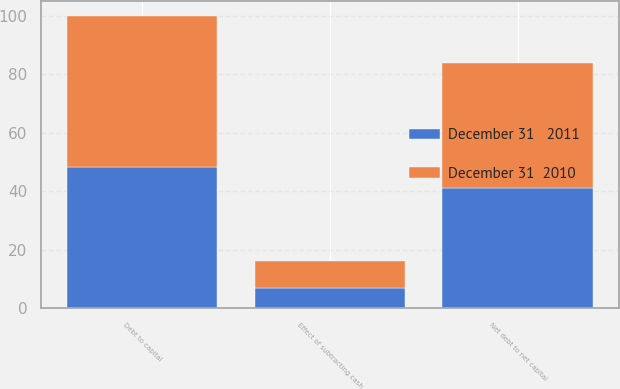Convert chart. <chart><loc_0><loc_0><loc_500><loc_500><stacked_bar_chart><ecel><fcel>Debt to capital<fcel>Effect of subtracting cash<fcel>Net debt to net capital<nl><fcel>December 31   2011<fcel>48.3<fcel>7.1<fcel>41.2<nl><fcel>December 31  2010<fcel>51.7<fcel>9<fcel>42.7<nl></chart> 